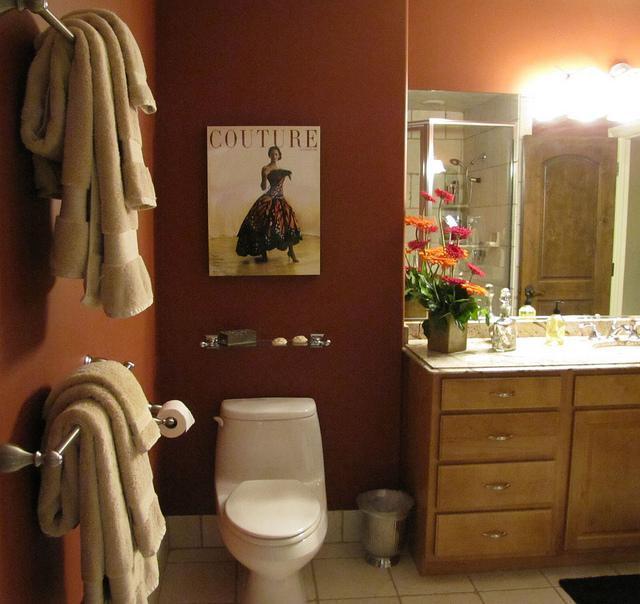What athlete's last name appears on the poster?
Indicate the correct response by choosing from the four available options to answer the question.
Options: Bo jackson, randy couture, wayne gretzky, jim those. Randy couture. 